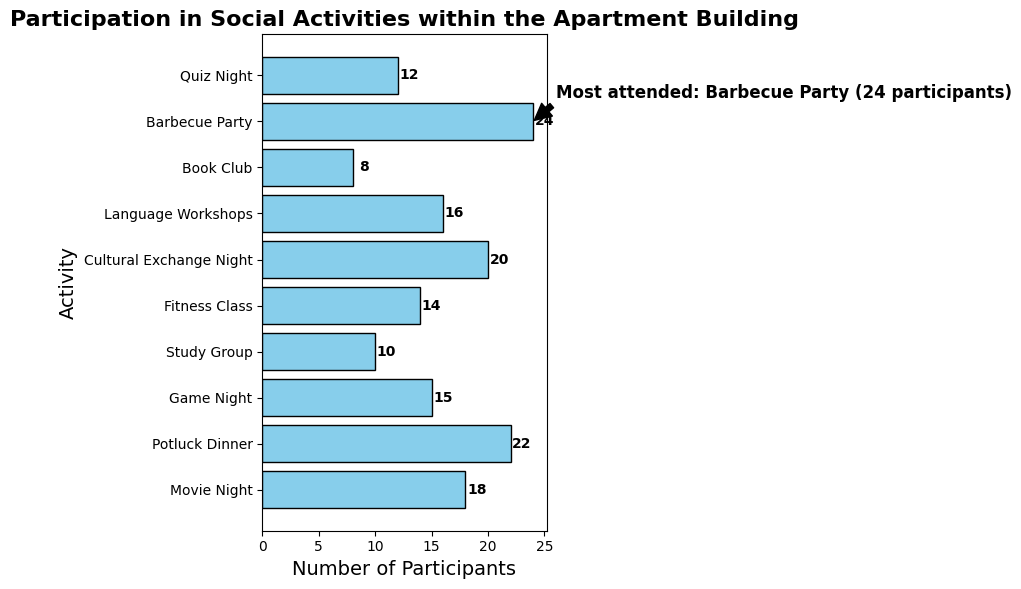Which social activity had the most participants? The annotation indicates that the Barbecue Party was the most attended activity, with 24 participants.
Answer: Barbecue Party Which activity had the fewest participants, and how many attended it? According to the bar chart, the Book Club had the fewest participants with a total of 8.
Answer: Book Club, 8 How many participants attended both the Potluck Dinner and Cultural Exchange Night combined? The number of participants for Potluck Dinner is 22, and for Cultural Exchange Night it is 20. Adding these numbers gives a total of 42.
Answer: 42 Is the number of participants in Movie Night greater than in Game Night? The bar for Movie Night has 18 participants, while Game Night has 15 participants, thus Movie Night has more participants.
Answer: Yes How much of a difference is there in participants between the Fitness Class and the Study Group? The number of participants in the Fitness Class is 14, and the Study Group has 10 participants. The difference is thus 14 - 10 = 4.
Answer: 4 Which activities have a similar number of participants, within a difference of 2? Movie Night has 18 participants and Language Workshops have 16 participants. Study Group has 10 participants and Quiz Night has 12 participants; both pairs have a difference of 2.
Answer: Movie Night and Language Workshops, Study Group and Quiz Night What's the average number of participants across all activities? Adding all participant numbers: (18 + 22 + 15 + 10 + 14 + 20 + 16 + 8 + 24 + 12) = 159. There are 10 activities, so the average is 159 / 10 = 15.9.
Answer: 15.9 How many activities had more than 15 participants? Counting bars with more than 15 participants: Movie Night (18), Potluck Dinner (22), Cultural Exchange Night (20), Language Workshops (16), and Barbecue Party (24). That makes 5 activities.
Answer: 5 What is the total number of participants in events that had fewer than 15 participants? Adding participants from events with fewer than 15: Game Night (15), Study Group (10), Fitness Class (14), Book Club (8), and Quiz Night (12) which totals 59 participants.
Answer: 59 